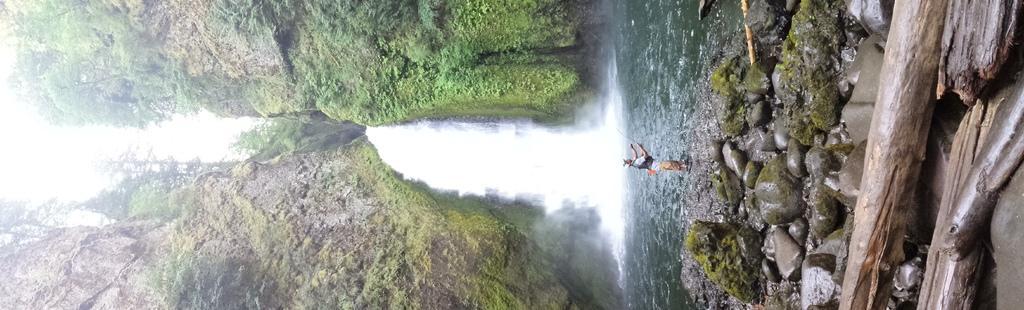Please provide a concise description of this image. There are logs, stones and a person standing on the right side, it seems like mountains and water in the center of the image. 